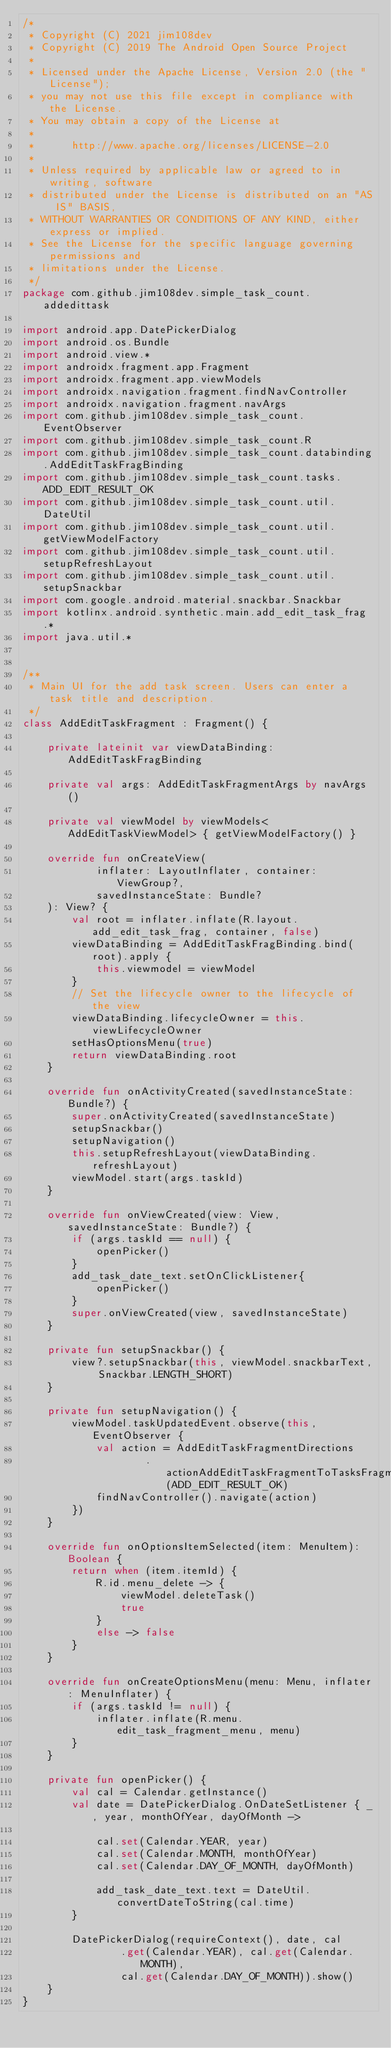Convert code to text. <code><loc_0><loc_0><loc_500><loc_500><_Kotlin_>/*
 * Copyright (C) 2021 jim108dev
 * Copyright (C) 2019 The Android Open Source Project
 *
 * Licensed under the Apache License, Version 2.0 (the "License");
 * you may not use this file except in compliance with the License.
 * You may obtain a copy of the License at
 *
 *      http://www.apache.org/licenses/LICENSE-2.0
 *
 * Unless required by applicable law or agreed to in writing, software
 * distributed under the License is distributed on an "AS IS" BASIS,
 * WITHOUT WARRANTIES OR CONDITIONS OF ANY KIND, either express or implied.
 * See the License for the specific language governing permissions and
 * limitations under the License.
 */
package com.github.jim108dev.simple_task_count.addedittask

import android.app.DatePickerDialog
import android.os.Bundle
import android.view.*
import androidx.fragment.app.Fragment
import androidx.fragment.app.viewModels
import androidx.navigation.fragment.findNavController
import androidx.navigation.fragment.navArgs
import com.github.jim108dev.simple_task_count.EventObserver
import com.github.jim108dev.simple_task_count.R
import com.github.jim108dev.simple_task_count.databinding.AddEditTaskFragBinding
import com.github.jim108dev.simple_task_count.tasks.ADD_EDIT_RESULT_OK
import com.github.jim108dev.simple_task_count.util.DateUtil
import com.github.jim108dev.simple_task_count.util.getViewModelFactory
import com.github.jim108dev.simple_task_count.util.setupRefreshLayout
import com.github.jim108dev.simple_task_count.util.setupSnackbar
import com.google.android.material.snackbar.Snackbar
import kotlinx.android.synthetic.main.add_edit_task_frag.*
import java.util.*


/**
 * Main UI for the add task screen. Users can enter a task title and description.
 */
class AddEditTaskFragment : Fragment() {

    private lateinit var viewDataBinding: AddEditTaskFragBinding

    private val args: AddEditTaskFragmentArgs by navArgs()

    private val viewModel by viewModels<AddEditTaskViewModel> { getViewModelFactory() }

    override fun onCreateView(
            inflater: LayoutInflater, container: ViewGroup?,
            savedInstanceState: Bundle?
    ): View? {
        val root = inflater.inflate(R.layout.add_edit_task_frag, container, false)
        viewDataBinding = AddEditTaskFragBinding.bind(root).apply {
            this.viewmodel = viewModel
        }
        // Set the lifecycle owner to the lifecycle of the view
        viewDataBinding.lifecycleOwner = this.viewLifecycleOwner
        setHasOptionsMenu(true)
        return viewDataBinding.root
    }

    override fun onActivityCreated(savedInstanceState: Bundle?) {
        super.onActivityCreated(savedInstanceState)
        setupSnackbar()
        setupNavigation()
        this.setupRefreshLayout(viewDataBinding.refreshLayout)
        viewModel.start(args.taskId)
    }

    override fun onViewCreated(view: View, savedInstanceState: Bundle?) {
        if (args.taskId == null) {
            openPicker()
        }
        add_task_date_text.setOnClickListener{
            openPicker()
        }
        super.onViewCreated(view, savedInstanceState)
    }

    private fun setupSnackbar() {
        view?.setupSnackbar(this, viewModel.snackbarText, Snackbar.LENGTH_SHORT)
    }

    private fun setupNavigation() {
        viewModel.taskUpdatedEvent.observe(this, EventObserver {
            val action = AddEditTaskFragmentDirections
                    .actionAddEditTaskFragmentToTasksFragment(ADD_EDIT_RESULT_OK)
            findNavController().navigate(action)
        })
    }

    override fun onOptionsItemSelected(item: MenuItem): Boolean {
        return when (item.itemId) {
            R.id.menu_delete -> {
                viewModel.deleteTask()
                true
            }
            else -> false
        }
    }

    override fun onCreateOptionsMenu(menu: Menu, inflater: MenuInflater) {
        if (args.taskId != null) {
            inflater.inflate(R.menu.edit_task_fragment_menu, menu)
        }
    }

    private fun openPicker() {
        val cal = Calendar.getInstance()
        val date = DatePickerDialog.OnDateSetListener { _, year, monthOfYear, dayOfMonth ->

            cal.set(Calendar.YEAR, year)
            cal.set(Calendar.MONTH, monthOfYear)
            cal.set(Calendar.DAY_OF_MONTH, dayOfMonth)

            add_task_date_text.text = DateUtil.convertDateToString(cal.time)
        }

        DatePickerDialog(requireContext(), date, cal
                .get(Calendar.YEAR), cal.get(Calendar.MONTH),
                cal.get(Calendar.DAY_OF_MONTH)).show()
    }
}
</code> 